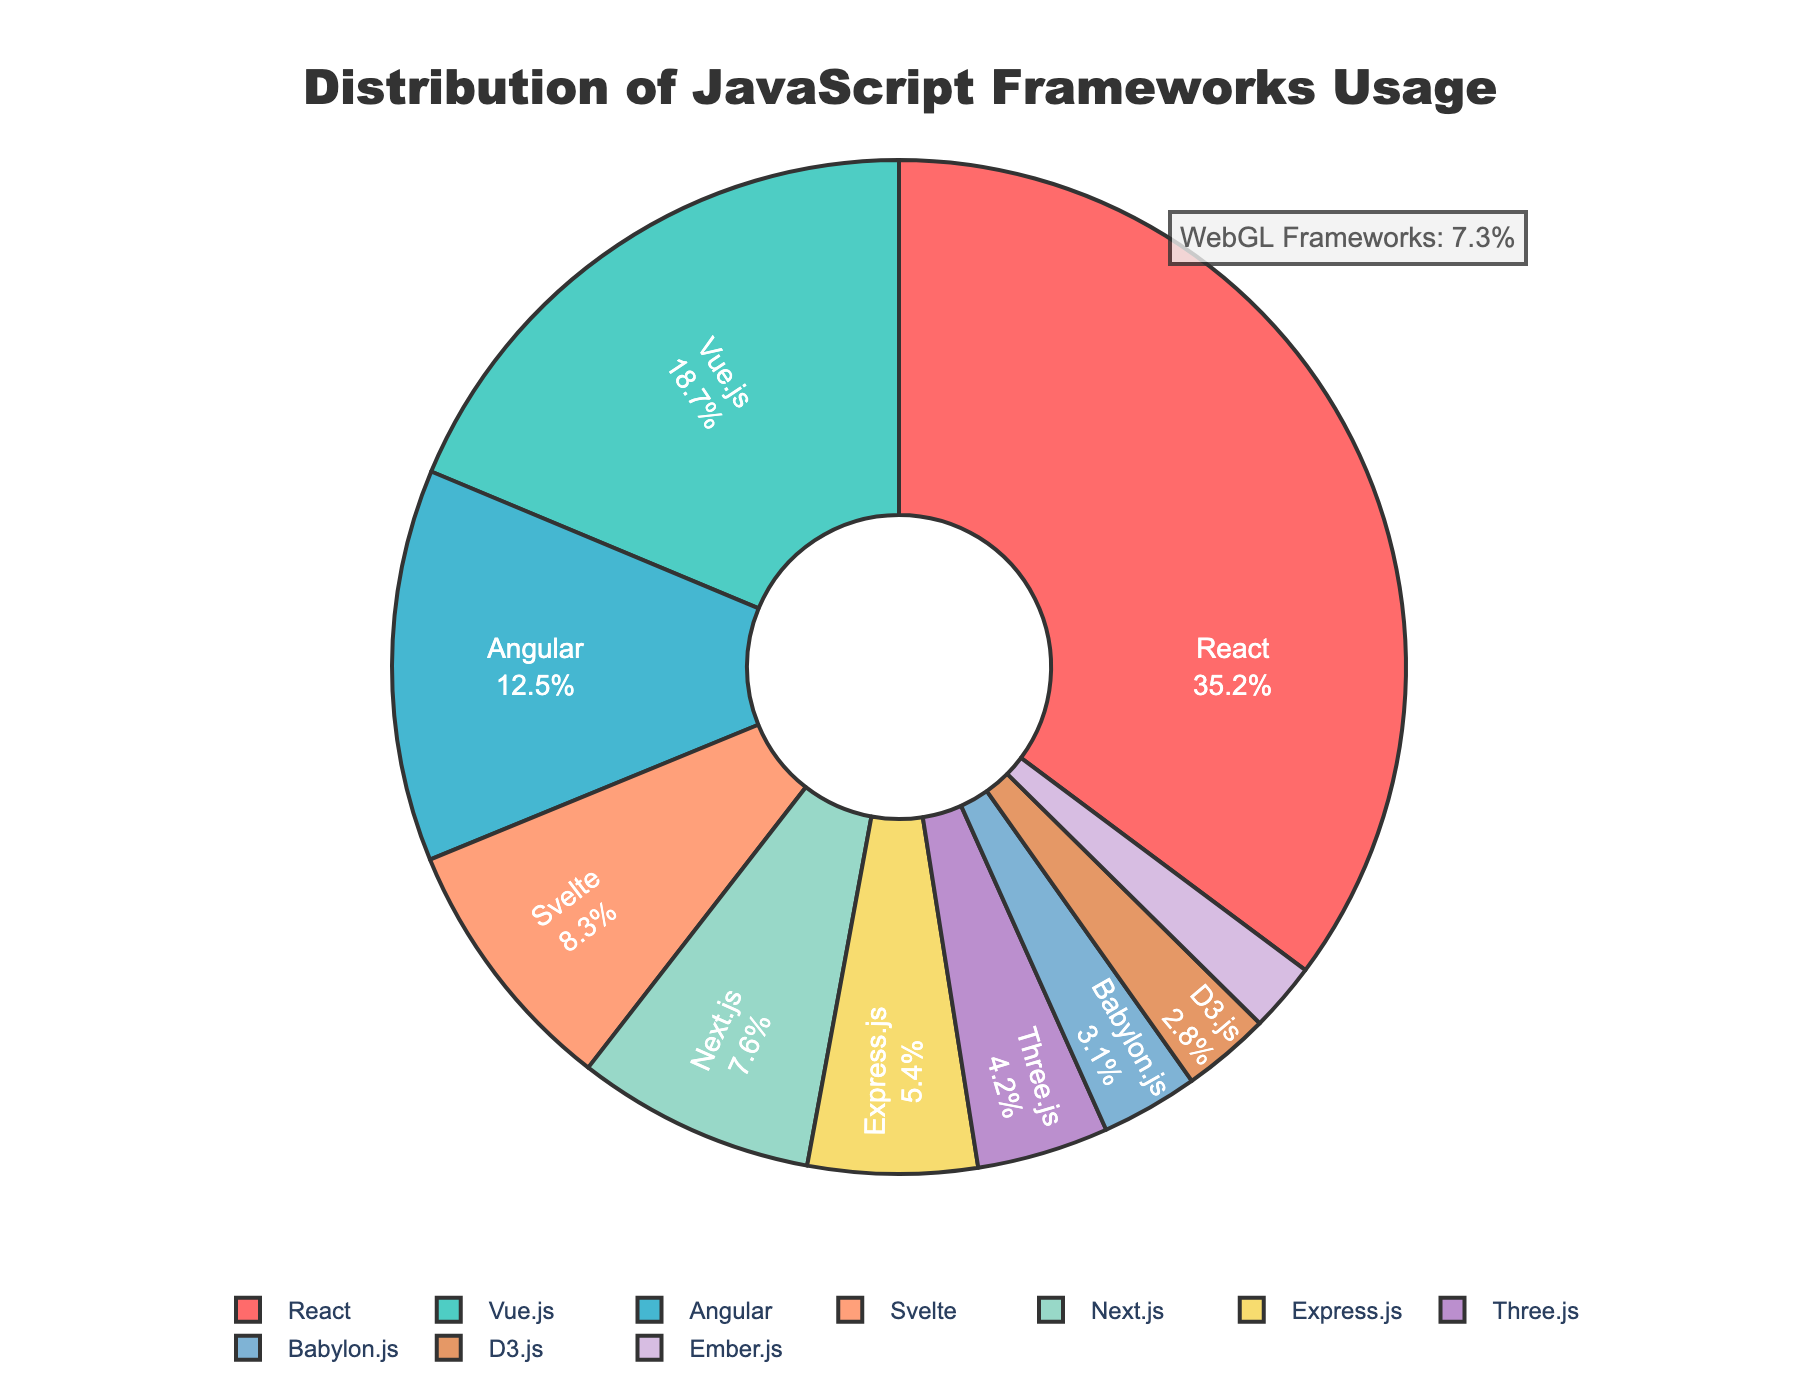What is the percentage of usage for React in web development? React is one of the frameworks listed in the pie chart. By looking at the corresponding segment labeled "React," we can see that the percentage value is 35.2%.
Answer: 35.2% Which framework has the second-highest usage after React? The framework with the highest usage is React at 35.2%. The second highest is determined by comparing the remaining segments' percentages. Vue.js, with 18.7%, is the second highest.
Answer: Vue.js What is the total percentage usage of WebGL frameworks (Three.js and Babylon.js)? The segments for Three.js and Babylon.js have percentages of 4.2% and 3.1%, respectively. Adding these together, 4.2 + 3.1 = 7.3%.
Answer: 7.3% Are there more frameworks with usage above or below 5%? To determine this, we count the number of frameworks above 5% (React, Vue.js, Angular, Svelte, Next.js) which totals 5, and the number below 5% (Express.js, Three.js, Babylon.js, D3.js, Ember.js) which also totals 5.
Answer: Equal Which framework has the smallest usage percentage and what is it? By examining the smallest segment in the pie chart, we see that Ember.js has the smallest usage percentage at 2.2%.
Answer: Ember.js, 2.2% How much greater is the usage of React compared to Angular? The React segment shows 35.2%, and the Angular segment shows 12.5%. The difference is calculated as 35.2 - 12.5 = 22.7%.
Answer: 22.7% What color represents the Svelte framework? By visually identifying the segment labeled "Svelte" in the pie chart, we can match it to its corresponding color, which is pinkish (#FFA07A).
Answer: pinkish Which framework categories are tagged with nearly identical colors, and what are those colors? By observing the pie chart, we note that D3.js (#E59866) and Ember.js (#D7BDE2) have distinct, yet visually somewhat similar pastel hues, making them appear close but not identical.
Answer: pastel colors What is the combined percentage usage for frameworks other than React, Vue.js, and Angular? Summing the percentages of the remaining frameworks: Svelte (8.3) + Next.js (7.6) + Express.js (5.4) + Three.js (4.2) + Babylon.js (3.1) + D3.js (2.8) + Ember.js (2.2) = 33.6%.
Answer: 33.6% 